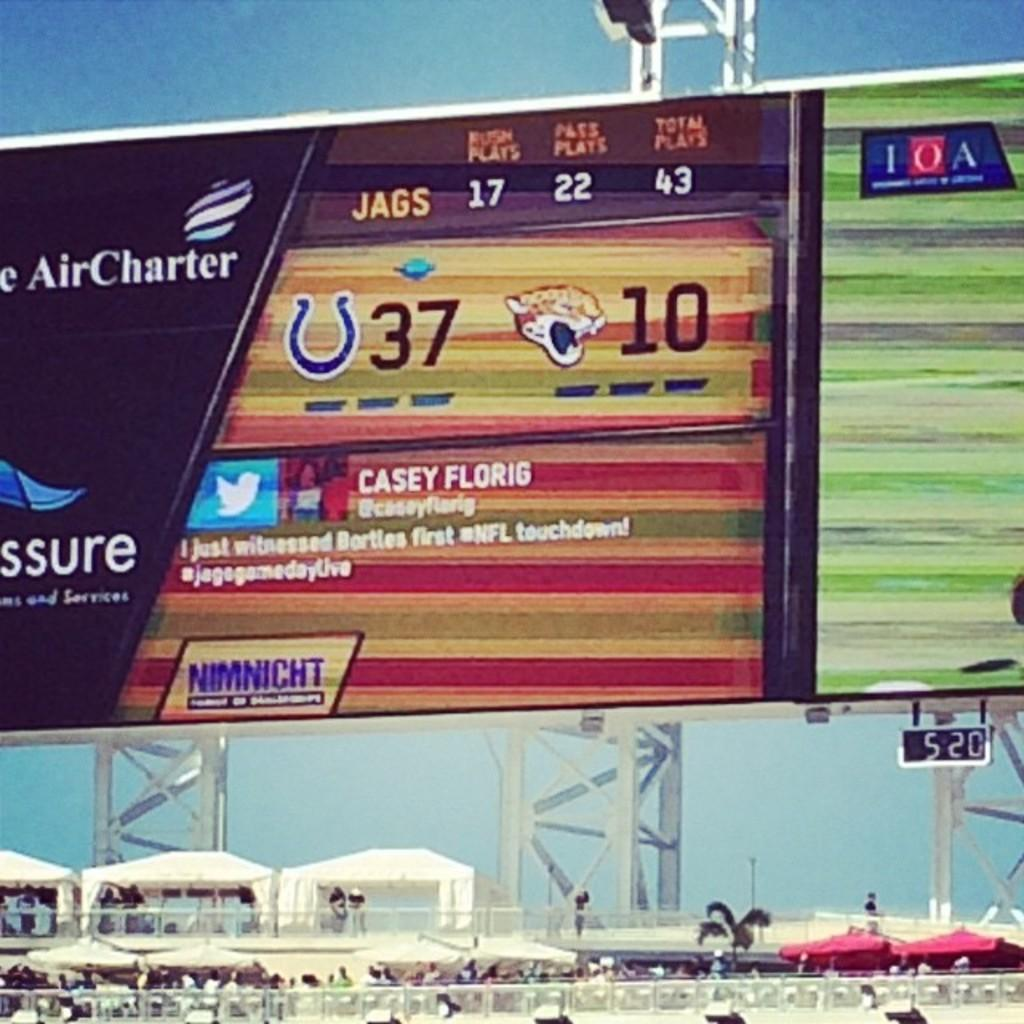Provide a one-sentence caption for the provided image. An electronic billboard displaying different advertisements and a tweet from someone named Casey Florig. 